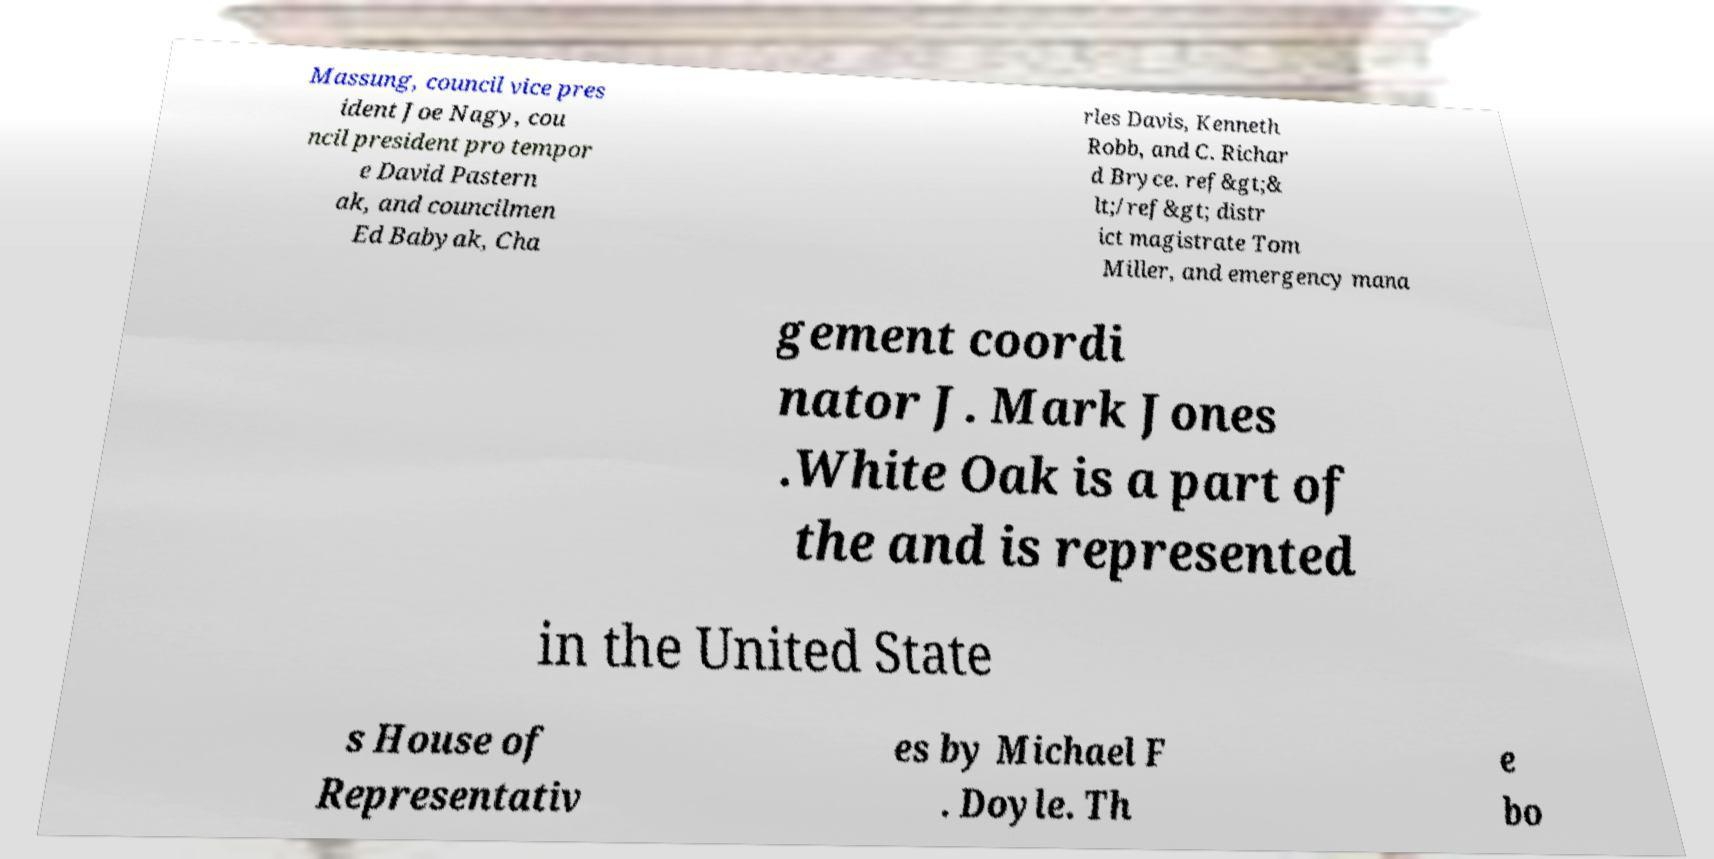I need the written content from this picture converted into text. Can you do that? Massung, council vice pres ident Joe Nagy, cou ncil president pro tempor e David Pastern ak, and councilmen Ed Babyak, Cha rles Davis, Kenneth Robb, and C. Richar d Bryce. ref&gt;& lt;/ref&gt; distr ict magistrate Tom Miller, and emergency mana gement coordi nator J. Mark Jones .White Oak is a part of the and is represented in the United State s House of Representativ es by Michael F . Doyle. Th e bo 